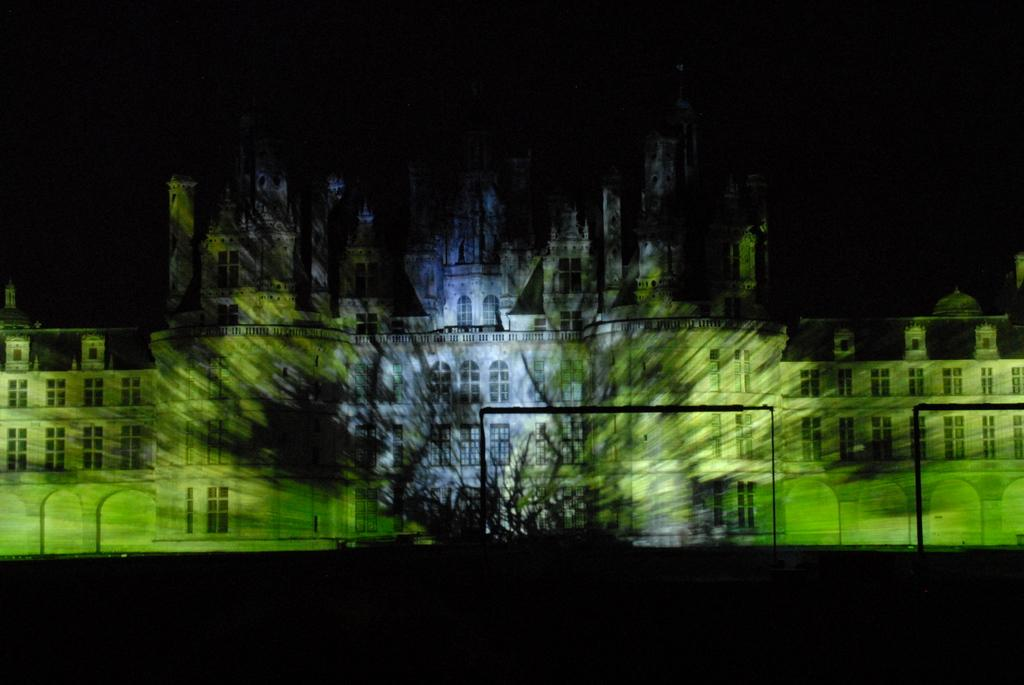What is the main subject of the image? There is a building in the image. What can be seen in the background of the image? The background of the image is completely dark. What type of teeth can be seen on the boy in the image? There is no boy present in the image, and therefore no teeth can be observed. 